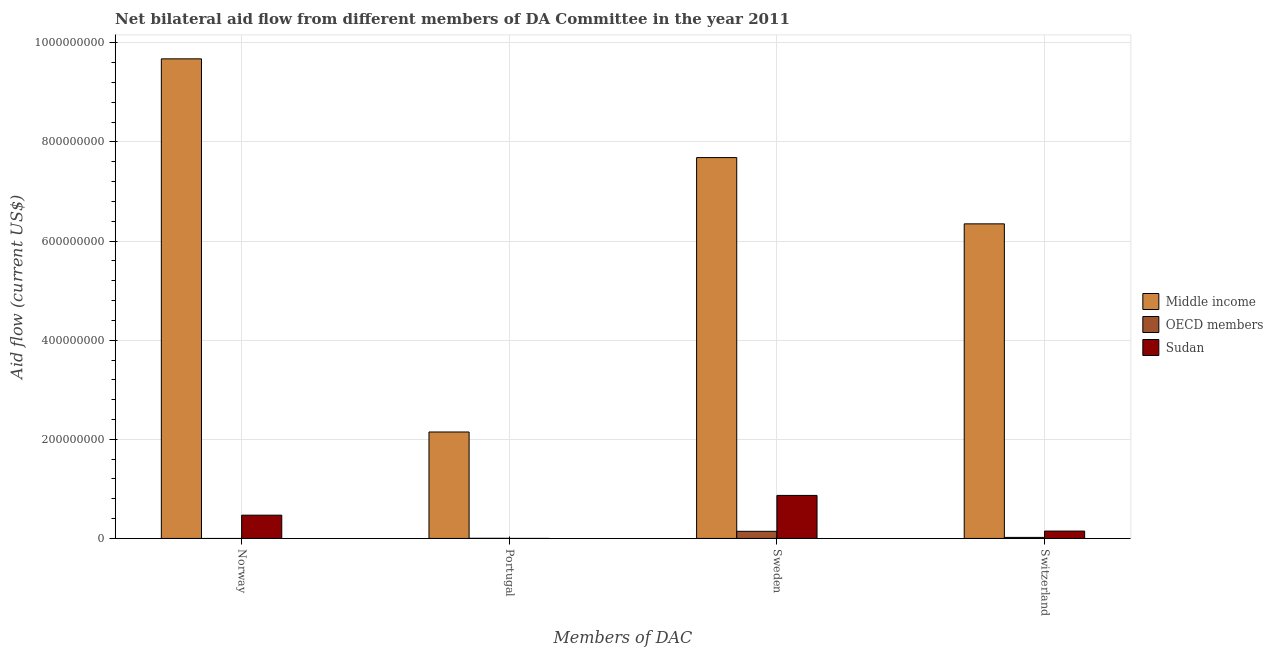How many different coloured bars are there?
Your answer should be very brief. 3. Are the number of bars per tick equal to the number of legend labels?
Your answer should be very brief. No. How many bars are there on the 1st tick from the left?
Give a very brief answer. 2. What is the label of the 4th group of bars from the left?
Your answer should be very brief. Switzerland. What is the amount of aid given by norway in Middle income?
Offer a very short reply. 9.68e+08. Across all countries, what is the maximum amount of aid given by portugal?
Make the answer very short. 2.15e+08. In which country was the amount of aid given by norway maximum?
Offer a terse response. Middle income. What is the total amount of aid given by norway in the graph?
Make the answer very short. 1.01e+09. What is the difference between the amount of aid given by sweden in Sudan and that in OECD members?
Provide a short and direct response. 7.24e+07. What is the difference between the amount of aid given by portugal in Sudan and the amount of aid given by sweden in Middle income?
Offer a very short reply. -7.68e+08. What is the average amount of aid given by switzerland per country?
Your answer should be very brief. 2.17e+08. What is the difference between the amount of aid given by sweden and amount of aid given by norway in Middle income?
Your answer should be compact. -1.99e+08. In how many countries, is the amount of aid given by portugal greater than 480000000 US$?
Your response must be concise. 0. What is the ratio of the amount of aid given by switzerland in Sudan to that in OECD members?
Offer a very short reply. 7.07. Is the amount of aid given by portugal in OECD members less than that in Middle income?
Provide a succinct answer. Yes. What is the difference between the highest and the second highest amount of aid given by switzerland?
Make the answer very short. 6.20e+08. What is the difference between the highest and the lowest amount of aid given by sweden?
Ensure brevity in your answer.  7.54e+08. Is the sum of the amount of aid given by portugal in Sudan and OECD members greater than the maximum amount of aid given by switzerland across all countries?
Your answer should be very brief. No. Is it the case that in every country, the sum of the amount of aid given by norway and amount of aid given by portugal is greater than the amount of aid given by sweden?
Your answer should be compact. No. How many bars are there?
Make the answer very short. 11. How many countries are there in the graph?
Ensure brevity in your answer.  3. What is the difference between two consecutive major ticks on the Y-axis?
Keep it short and to the point. 2.00e+08. Does the graph contain any zero values?
Your answer should be compact. Yes. Where does the legend appear in the graph?
Offer a terse response. Center right. How many legend labels are there?
Make the answer very short. 3. How are the legend labels stacked?
Offer a very short reply. Vertical. What is the title of the graph?
Your answer should be very brief. Net bilateral aid flow from different members of DA Committee in the year 2011. Does "Cyprus" appear as one of the legend labels in the graph?
Your answer should be very brief. No. What is the label or title of the X-axis?
Make the answer very short. Members of DAC. What is the Aid flow (current US$) in Middle income in Norway?
Your answer should be compact. 9.68e+08. What is the Aid flow (current US$) of OECD members in Norway?
Make the answer very short. 0. What is the Aid flow (current US$) of Sudan in Norway?
Give a very brief answer. 4.70e+07. What is the Aid flow (current US$) in Middle income in Portugal?
Make the answer very short. 2.15e+08. What is the Aid flow (current US$) in OECD members in Portugal?
Provide a short and direct response. 2.40e+05. What is the Aid flow (current US$) of Sudan in Portugal?
Provide a short and direct response. 10000. What is the Aid flow (current US$) in Middle income in Sweden?
Make the answer very short. 7.68e+08. What is the Aid flow (current US$) of OECD members in Sweden?
Give a very brief answer. 1.44e+07. What is the Aid flow (current US$) of Sudan in Sweden?
Ensure brevity in your answer.  8.68e+07. What is the Aid flow (current US$) of Middle income in Switzerland?
Ensure brevity in your answer.  6.35e+08. What is the Aid flow (current US$) in OECD members in Switzerland?
Your answer should be compact. 2.10e+06. What is the Aid flow (current US$) of Sudan in Switzerland?
Provide a short and direct response. 1.48e+07. Across all Members of DAC, what is the maximum Aid flow (current US$) of Middle income?
Provide a short and direct response. 9.68e+08. Across all Members of DAC, what is the maximum Aid flow (current US$) of OECD members?
Ensure brevity in your answer.  1.44e+07. Across all Members of DAC, what is the maximum Aid flow (current US$) in Sudan?
Offer a very short reply. 8.68e+07. Across all Members of DAC, what is the minimum Aid flow (current US$) of Middle income?
Make the answer very short. 2.15e+08. Across all Members of DAC, what is the minimum Aid flow (current US$) in OECD members?
Give a very brief answer. 0. What is the total Aid flow (current US$) of Middle income in the graph?
Make the answer very short. 2.59e+09. What is the total Aid flow (current US$) of OECD members in the graph?
Provide a short and direct response. 1.67e+07. What is the total Aid flow (current US$) in Sudan in the graph?
Make the answer very short. 1.49e+08. What is the difference between the Aid flow (current US$) in Middle income in Norway and that in Portugal?
Ensure brevity in your answer.  7.53e+08. What is the difference between the Aid flow (current US$) of Sudan in Norway and that in Portugal?
Keep it short and to the point. 4.70e+07. What is the difference between the Aid flow (current US$) of Middle income in Norway and that in Sweden?
Provide a short and direct response. 1.99e+08. What is the difference between the Aid flow (current US$) in Sudan in Norway and that in Sweden?
Offer a very short reply. -3.98e+07. What is the difference between the Aid flow (current US$) of Middle income in Norway and that in Switzerland?
Keep it short and to the point. 3.33e+08. What is the difference between the Aid flow (current US$) in Sudan in Norway and that in Switzerland?
Provide a short and direct response. 3.21e+07. What is the difference between the Aid flow (current US$) in Middle income in Portugal and that in Sweden?
Ensure brevity in your answer.  -5.54e+08. What is the difference between the Aid flow (current US$) of OECD members in Portugal and that in Sweden?
Your answer should be compact. -1.42e+07. What is the difference between the Aid flow (current US$) in Sudan in Portugal and that in Sweden?
Offer a terse response. -8.68e+07. What is the difference between the Aid flow (current US$) of Middle income in Portugal and that in Switzerland?
Make the answer very short. -4.20e+08. What is the difference between the Aid flow (current US$) in OECD members in Portugal and that in Switzerland?
Give a very brief answer. -1.86e+06. What is the difference between the Aid flow (current US$) in Sudan in Portugal and that in Switzerland?
Offer a terse response. -1.48e+07. What is the difference between the Aid flow (current US$) in Middle income in Sweden and that in Switzerland?
Ensure brevity in your answer.  1.34e+08. What is the difference between the Aid flow (current US$) in OECD members in Sweden and that in Switzerland?
Offer a terse response. 1.23e+07. What is the difference between the Aid flow (current US$) of Sudan in Sweden and that in Switzerland?
Offer a very short reply. 7.19e+07. What is the difference between the Aid flow (current US$) of Middle income in Norway and the Aid flow (current US$) of OECD members in Portugal?
Your response must be concise. 9.67e+08. What is the difference between the Aid flow (current US$) in Middle income in Norway and the Aid flow (current US$) in Sudan in Portugal?
Ensure brevity in your answer.  9.68e+08. What is the difference between the Aid flow (current US$) of Middle income in Norway and the Aid flow (current US$) of OECD members in Sweden?
Keep it short and to the point. 9.53e+08. What is the difference between the Aid flow (current US$) in Middle income in Norway and the Aid flow (current US$) in Sudan in Sweden?
Give a very brief answer. 8.81e+08. What is the difference between the Aid flow (current US$) of Middle income in Norway and the Aid flow (current US$) of OECD members in Switzerland?
Your answer should be very brief. 9.66e+08. What is the difference between the Aid flow (current US$) in Middle income in Norway and the Aid flow (current US$) in Sudan in Switzerland?
Make the answer very short. 9.53e+08. What is the difference between the Aid flow (current US$) of Middle income in Portugal and the Aid flow (current US$) of OECD members in Sweden?
Your response must be concise. 2.00e+08. What is the difference between the Aid flow (current US$) of Middle income in Portugal and the Aid flow (current US$) of Sudan in Sweden?
Your answer should be compact. 1.28e+08. What is the difference between the Aid flow (current US$) of OECD members in Portugal and the Aid flow (current US$) of Sudan in Sweden?
Make the answer very short. -8.66e+07. What is the difference between the Aid flow (current US$) of Middle income in Portugal and the Aid flow (current US$) of OECD members in Switzerland?
Provide a succinct answer. 2.13e+08. What is the difference between the Aid flow (current US$) in Middle income in Portugal and the Aid flow (current US$) in Sudan in Switzerland?
Make the answer very short. 2.00e+08. What is the difference between the Aid flow (current US$) in OECD members in Portugal and the Aid flow (current US$) in Sudan in Switzerland?
Your answer should be very brief. -1.46e+07. What is the difference between the Aid flow (current US$) of Middle income in Sweden and the Aid flow (current US$) of OECD members in Switzerland?
Your response must be concise. 7.66e+08. What is the difference between the Aid flow (current US$) in Middle income in Sweden and the Aid flow (current US$) in Sudan in Switzerland?
Your answer should be compact. 7.54e+08. What is the difference between the Aid flow (current US$) of OECD members in Sweden and the Aid flow (current US$) of Sudan in Switzerland?
Offer a very short reply. -4.60e+05. What is the average Aid flow (current US$) in Middle income per Members of DAC?
Your response must be concise. 6.46e+08. What is the average Aid flow (current US$) in OECD members per Members of DAC?
Offer a very short reply. 4.18e+06. What is the average Aid flow (current US$) in Sudan per Members of DAC?
Offer a terse response. 3.72e+07. What is the difference between the Aid flow (current US$) in Middle income and Aid flow (current US$) in Sudan in Norway?
Your answer should be very brief. 9.21e+08. What is the difference between the Aid flow (current US$) in Middle income and Aid flow (current US$) in OECD members in Portugal?
Give a very brief answer. 2.15e+08. What is the difference between the Aid flow (current US$) in Middle income and Aid flow (current US$) in Sudan in Portugal?
Provide a succinct answer. 2.15e+08. What is the difference between the Aid flow (current US$) of Middle income and Aid flow (current US$) of OECD members in Sweden?
Keep it short and to the point. 7.54e+08. What is the difference between the Aid flow (current US$) in Middle income and Aid flow (current US$) in Sudan in Sweden?
Your answer should be compact. 6.82e+08. What is the difference between the Aid flow (current US$) of OECD members and Aid flow (current US$) of Sudan in Sweden?
Give a very brief answer. -7.24e+07. What is the difference between the Aid flow (current US$) in Middle income and Aid flow (current US$) in OECD members in Switzerland?
Make the answer very short. 6.33e+08. What is the difference between the Aid flow (current US$) of Middle income and Aid flow (current US$) of Sudan in Switzerland?
Offer a terse response. 6.20e+08. What is the difference between the Aid flow (current US$) of OECD members and Aid flow (current US$) of Sudan in Switzerland?
Offer a terse response. -1.28e+07. What is the ratio of the Aid flow (current US$) in Middle income in Norway to that in Portugal?
Provide a short and direct response. 4.51. What is the ratio of the Aid flow (current US$) of Sudan in Norway to that in Portugal?
Offer a terse response. 4696. What is the ratio of the Aid flow (current US$) in Middle income in Norway to that in Sweden?
Keep it short and to the point. 1.26. What is the ratio of the Aid flow (current US$) in Sudan in Norway to that in Sweden?
Your answer should be very brief. 0.54. What is the ratio of the Aid flow (current US$) in Middle income in Norway to that in Switzerland?
Provide a succinct answer. 1.52. What is the ratio of the Aid flow (current US$) of Sudan in Norway to that in Switzerland?
Provide a short and direct response. 3.16. What is the ratio of the Aid flow (current US$) in Middle income in Portugal to that in Sweden?
Offer a terse response. 0.28. What is the ratio of the Aid flow (current US$) of OECD members in Portugal to that in Sweden?
Keep it short and to the point. 0.02. What is the ratio of the Aid flow (current US$) in Middle income in Portugal to that in Switzerland?
Ensure brevity in your answer.  0.34. What is the ratio of the Aid flow (current US$) of OECD members in Portugal to that in Switzerland?
Your answer should be very brief. 0.11. What is the ratio of the Aid flow (current US$) in Sudan in Portugal to that in Switzerland?
Make the answer very short. 0. What is the ratio of the Aid flow (current US$) in Middle income in Sweden to that in Switzerland?
Make the answer very short. 1.21. What is the ratio of the Aid flow (current US$) in OECD members in Sweden to that in Switzerland?
Offer a terse response. 6.85. What is the ratio of the Aid flow (current US$) in Sudan in Sweden to that in Switzerland?
Make the answer very short. 5.84. What is the difference between the highest and the second highest Aid flow (current US$) of Middle income?
Provide a succinct answer. 1.99e+08. What is the difference between the highest and the second highest Aid flow (current US$) in OECD members?
Offer a very short reply. 1.23e+07. What is the difference between the highest and the second highest Aid flow (current US$) of Sudan?
Provide a succinct answer. 3.98e+07. What is the difference between the highest and the lowest Aid flow (current US$) in Middle income?
Provide a short and direct response. 7.53e+08. What is the difference between the highest and the lowest Aid flow (current US$) of OECD members?
Your response must be concise. 1.44e+07. What is the difference between the highest and the lowest Aid flow (current US$) of Sudan?
Keep it short and to the point. 8.68e+07. 